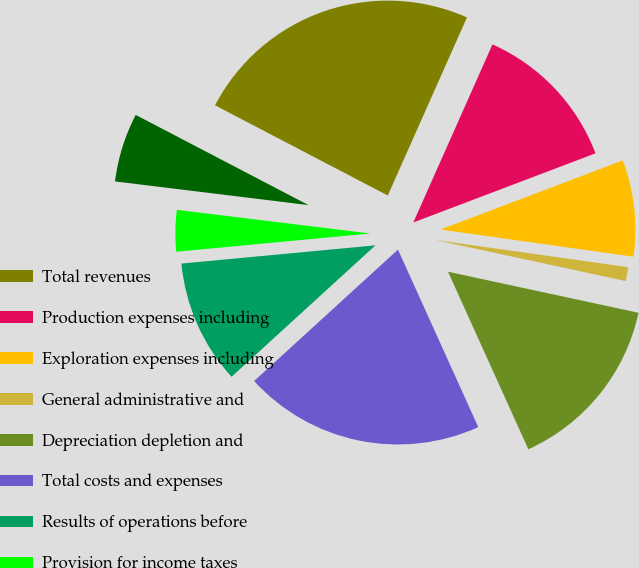<chart> <loc_0><loc_0><loc_500><loc_500><pie_chart><fcel>Total revenues<fcel>Production expenses including<fcel>Exploration expenses including<fcel>General administrative and<fcel>Depreciation depletion and<fcel>Total costs and expenses<fcel>Results of operations before<fcel>Provision for income taxes<fcel>Results of operations<nl><fcel>24.0%<fcel>12.57%<fcel>8.0%<fcel>1.15%<fcel>14.86%<fcel>19.98%<fcel>10.29%<fcel>3.43%<fcel>5.72%<nl></chart> 